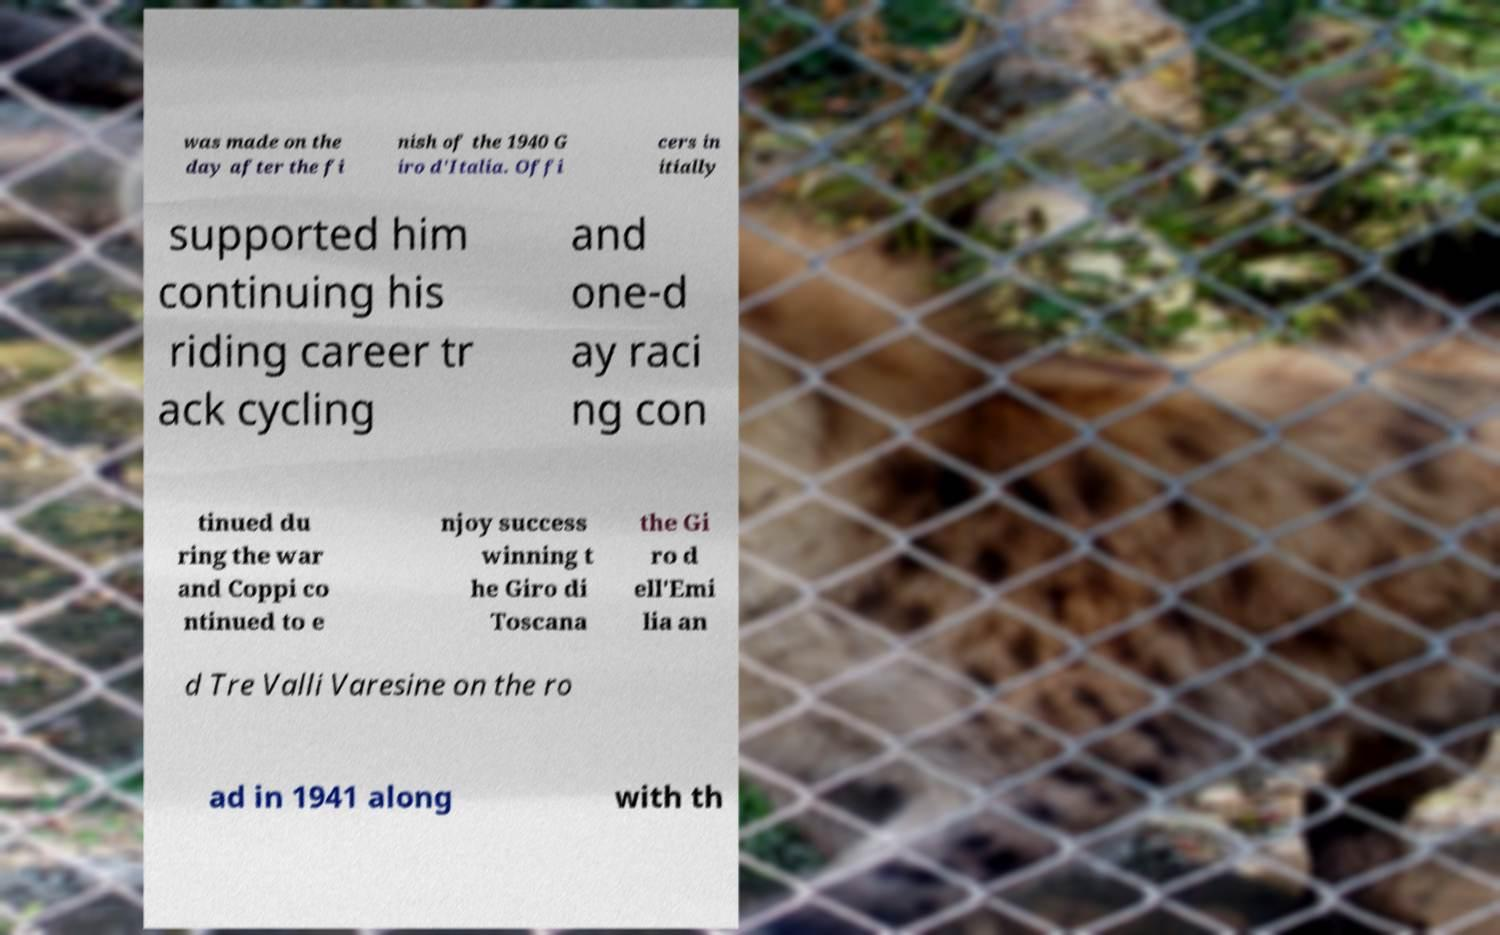Please identify and transcribe the text found in this image. was made on the day after the fi nish of the 1940 G iro d'Italia. Offi cers in itially supported him continuing his riding career tr ack cycling and one-d ay raci ng con tinued du ring the war and Coppi co ntinued to e njoy success winning t he Giro di Toscana the Gi ro d ell'Emi lia an d Tre Valli Varesine on the ro ad in 1941 along with th 